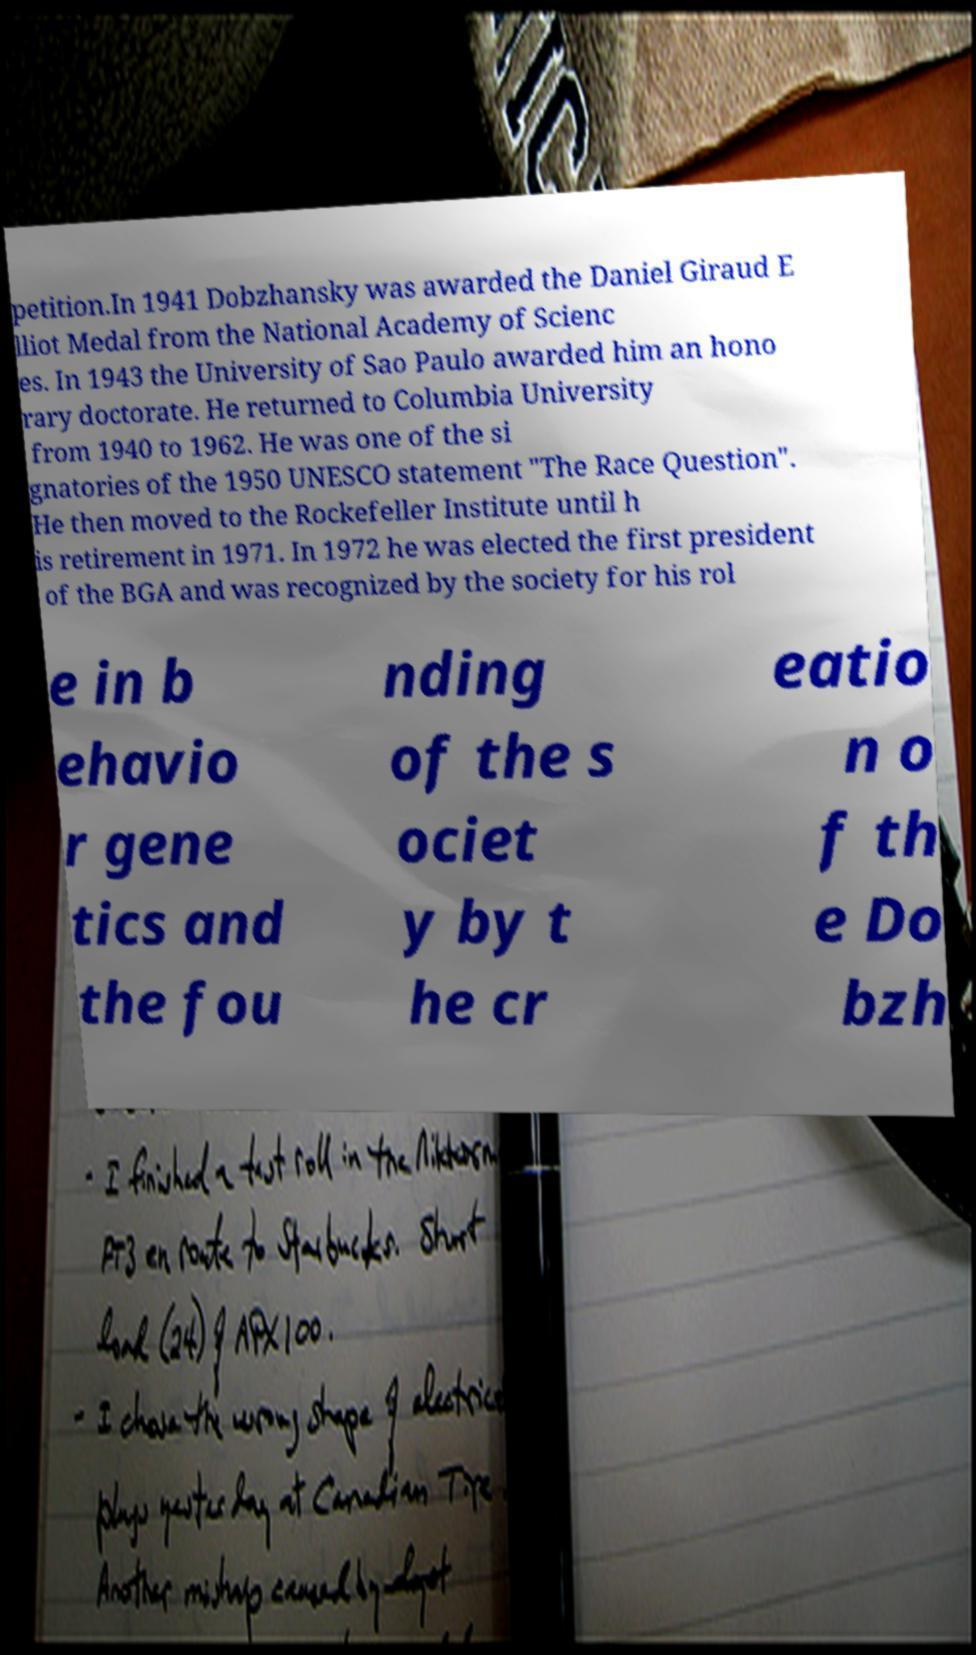Please identify and transcribe the text found in this image. petition.In 1941 Dobzhansky was awarded the Daniel Giraud E lliot Medal from the National Academy of Scienc es. In 1943 the University of Sao Paulo awarded him an hono rary doctorate. He returned to Columbia University from 1940 to 1962. He was one of the si gnatories of the 1950 UNESCO statement "The Race Question". He then moved to the Rockefeller Institute until h is retirement in 1971. In 1972 he was elected the first president of the BGA and was recognized by the society for his rol e in b ehavio r gene tics and the fou nding of the s ociet y by t he cr eatio n o f th e Do bzh 